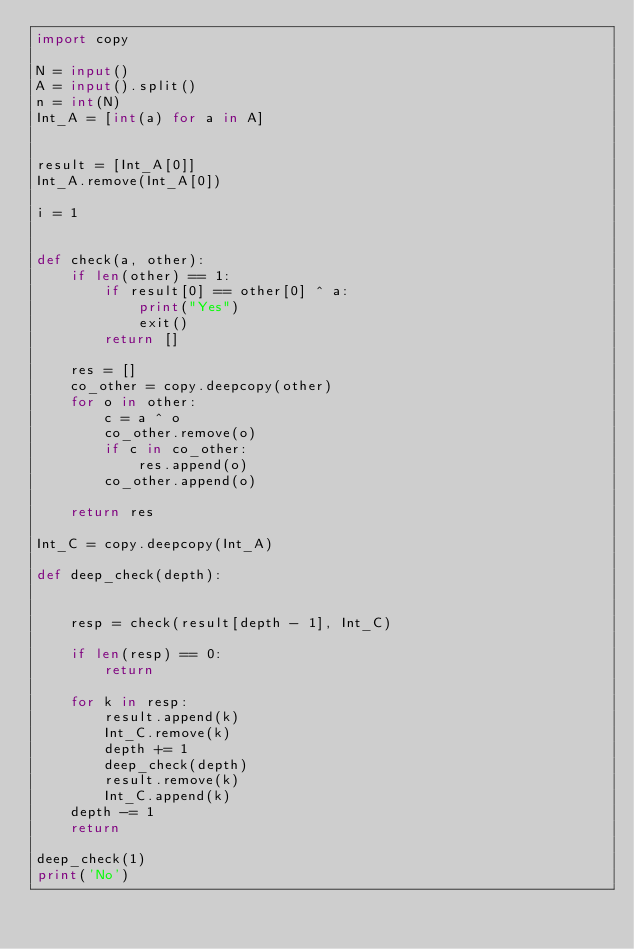Convert code to text. <code><loc_0><loc_0><loc_500><loc_500><_Python_>import copy

N = input()
A = input().split()
n = int(N)
Int_A = [int(a) for a in A]


result = [Int_A[0]]
Int_A.remove(Int_A[0])

i = 1


def check(a, other):
    if len(other) == 1:
        if result[0] == other[0] ^ a:
            print("Yes")
            exit()
        return []

    res = []
    co_other = copy.deepcopy(other)
    for o in other:
        c = a ^ o
        co_other.remove(o)
        if c in co_other:
            res.append(o)
        co_other.append(o)

    return res

Int_C = copy.deepcopy(Int_A)

def deep_check(depth):


    resp = check(result[depth - 1], Int_C)

    if len(resp) == 0:
        return

    for k in resp:
        result.append(k)
        Int_C.remove(k)
        depth += 1
        deep_check(depth)
        result.remove(k)
        Int_C.append(k)
    depth -= 1
    return

deep_check(1)
print('No')

</code> 